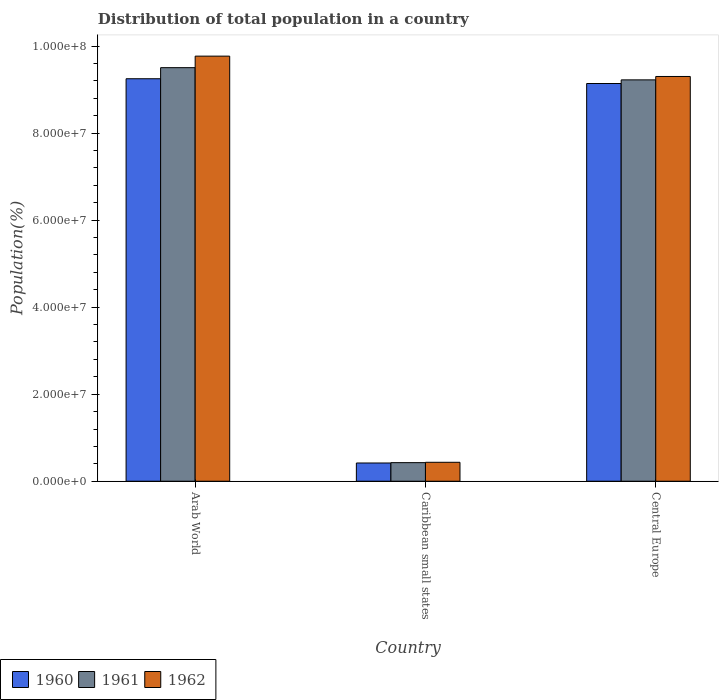How many different coloured bars are there?
Make the answer very short. 3. Are the number of bars on each tick of the X-axis equal?
Your response must be concise. Yes. How many bars are there on the 1st tick from the right?
Provide a short and direct response. 3. What is the label of the 3rd group of bars from the left?
Give a very brief answer. Central Europe. What is the population of in 1960 in Arab World?
Offer a terse response. 9.25e+07. Across all countries, what is the maximum population of in 1962?
Give a very brief answer. 9.77e+07. Across all countries, what is the minimum population of in 1962?
Ensure brevity in your answer.  4.35e+06. In which country was the population of in 1961 maximum?
Provide a succinct answer. Arab World. In which country was the population of in 1960 minimum?
Provide a succinct answer. Caribbean small states. What is the total population of in 1960 in the graph?
Ensure brevity in your answer.  1.88e+08. What is the difference between the population of in 1960 in Arab World and that in Central Europe?
Your answer should be very brief. 1.09e+06. What is the difference between the population of in 1961 in Central Europe and the population of in 1960 in Caribbean small states?
Offer a very short reply. 8.80e+07. What is the average population of in 1960 per country?
Provide a short and direct response. 6.27e+07. What is the difference between the population of of/in 1962 and population of of/in 1961 in Central Europe?
Provide a succinct answer. 7.78e+05. In how many countries, is the population of in 1962 greater than 60000000 %?
Your answer should be compact. 2. What is the ratio of the population of in 1961 in Arab World to that in Caribbean small states?
Ensure brevity in your answer.  22.25. Is the population of in 1962 in Arab World less than that in Caribbean small states?
Keep it short and to the point. No. What is the difference between the highest and the second highest population of in 1961?
Give a very brief answer. -9.08e+07. What is the difference between the highest and the lowest population of in 1960?
Your response must be concise. 8.83e+07. In how many countries, is the population of in 1960 greater than the average population of in 1960 taken over all countries?
Provide a short and direct response. 2. Is the sum of the population of in 1961 in Arab World and Central Europe greater than the maximum population of in 1962 across all countries?
Provide a succinct answer. Yes. Are all the bars in the graph horizontal?
Make the answer very short. No. How many countries are there in the graph?
Provide a short and direct response. 3. Are the values on the major ticks of Y-axis written in scientific E-notation?
Provide a short and direct response. Yes. Where does the legend appear in the graph?
Make the answer very short. Bottom left. How are the legend labels stacked?
Ensure brevity in your answer.  Horizontal. What is the title of the graph?
Give a very brief answer. Distribution of total population in a country. Does "1989" appear as one of the legend labels in the graph?
Your response must be concise. No. What is the label or title of the Y-axis?
Ensure brevity in your answer.  Population(%). What is the Population(%) in 1960 in Arab World?
Offer a very short reply. 9.25e+07. What is the Population(%) of 1961 in Arab World?
Your answer should be very brief. 9.50e+07. What is the Population(%) in 1962 in Arab World?
Your response must be concise. 9.77e+07. What is the Population(%) of 1960 in Caribbean small states?
Your response must be concise. 4.19e+06. What is the Population(%) of 1961 in Caribbean small states?
Give a very brief answer. 4.27e+06. What is the Population(%) in 1962 in Caribbean small states?
Offer a terse response. 4.35e+06. What is the Population(%) of 1960 in Central Europe?
Provide a succinct answer. 9.14e+07. What is the Population(%) of 1961 in Central Europe?
Ensure brevity in your answer.  9.22e+07. What is the Population(%) of 1962 in Central Europe?
Give a very brief answer. 9.30e+07. Across all countries, what is the maximum Population(%) in 1960?
Make the answer very short. 9.25e+07. Across all countries, what is the maximum Population(%) of 1961?
Keep it short and to the point. 9.50e+07. Across all countries, what is the maximum Population(%) in 1962?
Give a very brief answer. 9.77e+07. Across all countries, what is the minimum Population(%) of 1960?
Offer a very short reply. 4.19e+06. Across all countries, what is the minimum Population(%) in 1961?
Ensure brevity in your answer.  4.27e+06. Across all countries, what is the minimum Population(%) of 1962?
Your response must be concise. 4.35e+06. What is the total Population(%) of 1960 in the graph?
Ensure brevity in your answer.  1.88e+08. What is the total Population(%) in 1961 in the graph?
Your answer should be very brief. 1.92e+08. What is the total Population(%) of 1962 in the graph?
Offer a very short reply. 1.95e+08. What is the difference between the Population(%) in 1960 in Arab World and that in Caribbean small states?
Give a very brief answer. 8.83e+07. What is the difference between the Population(%) of 1961 in Arab World and that in Caribbean small states?
Make the answer very short. 9.08e+07. What is the difference between the Population(%) of 1962 in Arab World and that in Caribbean small states?
Your response must be concise. 9.33e+07. What is the difference between the Population(%) of 1960 in Arab World and that in Central Europe?
Offer a terse response. 1.09e+06. What is the difference between the Population(%) in 1961 in Arab World and that in Central Europe?
Give a very brief answer. 2.80e+06. What is the difference between the Population(%) in 1962 in Arab World and that in Central Europe?
Provide a succinct answer. 4.68e+06. What is the difference between the Population(%) in 1960 in Caribbean small states and that in Central Europe?
Make the answer very short. -8.72e+07. What is the difference between the Population(%) of 1961 in Caribbean small states and that in Central Europe?
Provide a short and direct response. -8.80e+07. What is the difference between the Population(%) of 1962 in Caribbean small states and that in Central Europe?
Provide a short and direct response. -8.87e+07. What is the difference between the Population(%) in 1960 in Arab World and the Population(%) in 1961 in Caribbean small states?
Make the answer very short. 8.82e+07. What is the difference between the Population(%) of 1960 in Arab World and the Population(%) of 1962 in Caribbean small states?
Make the answer very short. 8.81e+07. What is the difference between the Population(%) of 1961 in Arab World and the Population(%) of 1962 in Caribbean small states?
Ensure brevity in your answer.  9.07e+07. What is the difference between the Population(%) in 1960 in Arab World and the Population(%) in 1961 in Central Europe?
Keep it short and to the point. 2.59e+05. What is the difference between the Population(%) of 1960 in Arab World and the Population(%) of 1962 in Central Europe?
Your response must be concise. -5.19e+05. What is the difference between the Population(%) of 1961 in Arab World and the Population(%) of 1962 in Central Europe?
Make the answer very short. 2.03e+06. What is the difference between the Population(%) in 1960 in Caribbean small states and the Population(%) in 1961 in Central Europe?
Your response must be concise. -8.80e+07. What is the difference between the Population(%) in 1960 in Caribbean small states and the Population(%) in 1962 in Central Europe?
Offer a very short reply. -8.88e+07. What is the difference between the Population(%) in 1961 in Caribbean small states and the Population(%) in 1962 in Central Europe?
Give a very brief answer. -8.87e+07. What is the average Population(%) of 1960 per country?
Offer a very short reply. 6.27e+07. What is the average Population(%) of 1961 per country?
Your answer should be very brief. 6.38e+07. What is the average Population(%) of 1962 per country?
Your response must be concise. 6.50e+07. What is the difference between the Population(%) in 1960 and Population(%) in 1961 in Arab World?
Your answer should be very brief. -2.55e+06. What is the difference between the Population(%) of 1960 and Population(%) of 1962 in Arab World?
Ensure brevity in your answer.  -5.20e+06. What is the difference between the Population(%) of 1961 and Population(%) of 1962 in Arab World?
Provide a short and direct response. -2.65e+06. What is the difference between the Population(%) of 1960 and Population(%) of 1961 in Caribbean small states?
Make the answer very short. -8.01e+04. What is the difference between the Population(%) in 1960 and Population(%) in 1962 in Caribbean small states?
Provide a short and direct response. -1.63e+05. What is the difference between the Population(%) in 1961 and Population(%) in 1962 in Caribbean small states?
Ensure brevity in your answer.  -8.25e+04. What is the difference between the Population(%) in 1960 and Population(%) in 1961 in Central Europe?
Your response must be concise. -8.36e+05. What is the difference between the Population(%) in 1960 and Population(%) in 1962 in Central Europe?
Your answer should be very brief. -1.61e+06. What is the difference between the Population(%) in 1961 and Population(%) in 1962 in Central Europe?
Keep it short and to the point. -7.78e+05. What is the ratio of the Population(%) of 1960 in Arab World to that in Caribbean small states?
Make the answer very short. 22.07. What is the ratio of the Population(%) in 1961 in Arab World to that in Caribbean small states?
Your answer should be very brief. 22.25. What is the ratio of the Population(%) of 1962 in Arab World to that in Caribbean small states?
Make the answer very short. 22.44. What is the ratio of the Population(%) in 1960 in Arab World to that in Central Europe?
Provide a short and direct response. 1.01. What is the ratio of the Population(%) in 1961 in Arab World to that in Central Europe?
Provide a short and direct response. 1.03. What is the ratio of the Population(%) of 1962 in Arab World to that in Central Europe?
Give a very brief answer. 1.05. What is the ratio of the Population(%) in 1960 in Caribbean small states to that in Central Europe?
Ensure brevity in your answer.  0.05. What is the ratio of the Population(%) in 1961 in Caribbean small states to that in Central Europe?
Your answer should be very brief. 0.05. What is the ratio of the Population(%) in 1962 in Caribbean small states to that in Central Europe?
Provide a succinct answer. 0.05. What is the difference between the highest and the second highest Population(%) in 1960?
Offer a very short reply. 1.09e+06. What is the difference between the highest and the second highest Population(%) in 1961?
Offer a terse response. 2.80e+06. What is the difference between the highest and the second highest Population(%) in 1962?
Offer a terse response. 4.68e+06. What is the difference between the highest and the lowest Population(%) in 1960?
Keep it short and to the point. 8.83e+07. What is the difference between the highest and the lowest Population(%) in 1961?
Give a very brief answer. 9.08e+07. What is the difference between the highest and the lowest Population(%) of 1962?
Keep it short and to the point. 9.33e+07. 